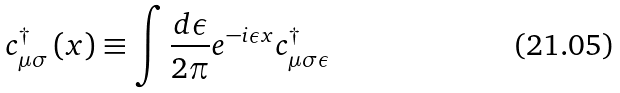Convert formula to latex. <formula><loc_0><loc_0><loc_500><loc_500>c ^ { \dagger } _ { \mu \sigma } \left ( x \right ) \equiv \int \frac { d \epsilon } { 2 \pi } e ^ { - i \epsilon x } c ^ { \dagger } _ { \mu \sigma \epsilon }</formula> 